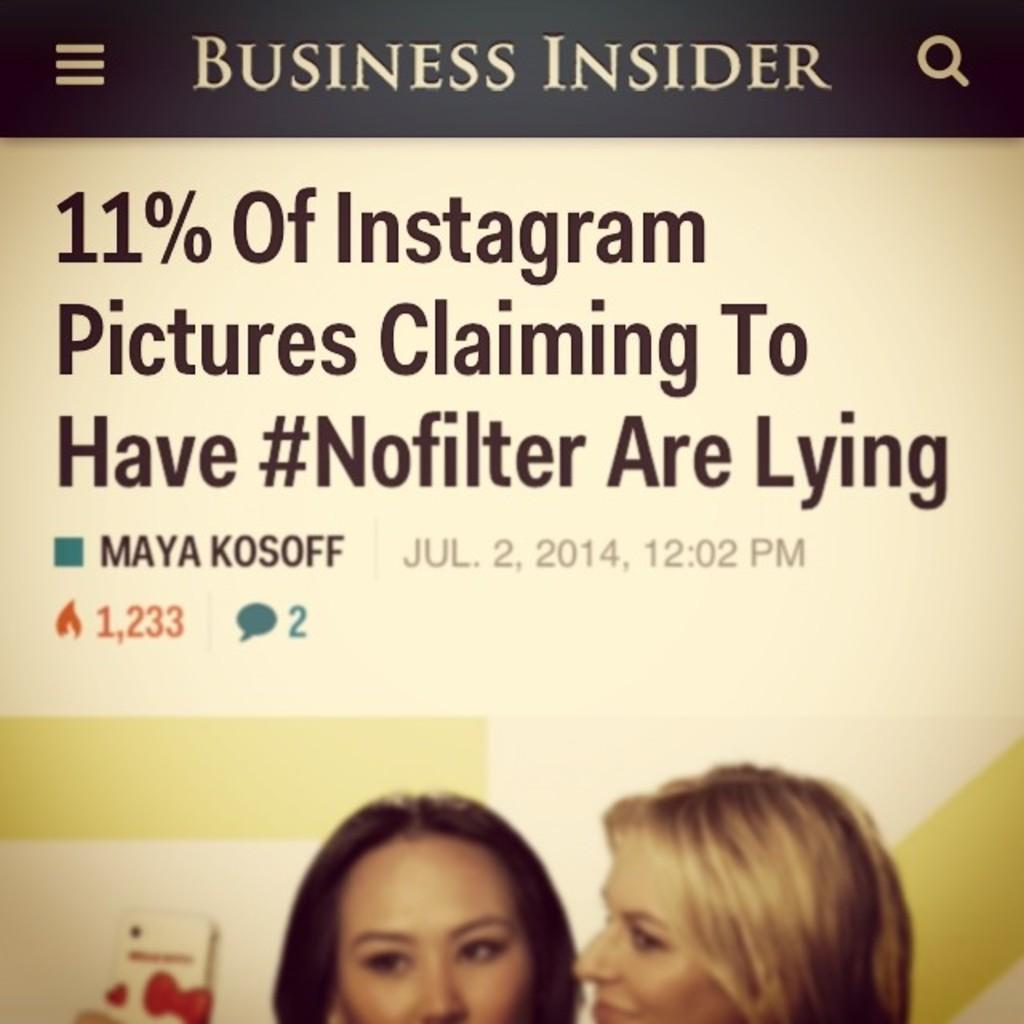What is present in the image that contains information or visuals? There is a poster in the image. What can be found on the poster besides images? The poster contains text. What type of images are on the poster? The poster has pictures of persons on it. How many rabbits are visible on the poster in the image? There are no rabbits present on the poster in the image. What type of bit is used to hold the poster in place? There is no information about a bit being used to hold the poster in place in the image. 